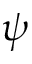<formula> <loc_0><loc_0><loc_500><loc_500>\psi</formula> 